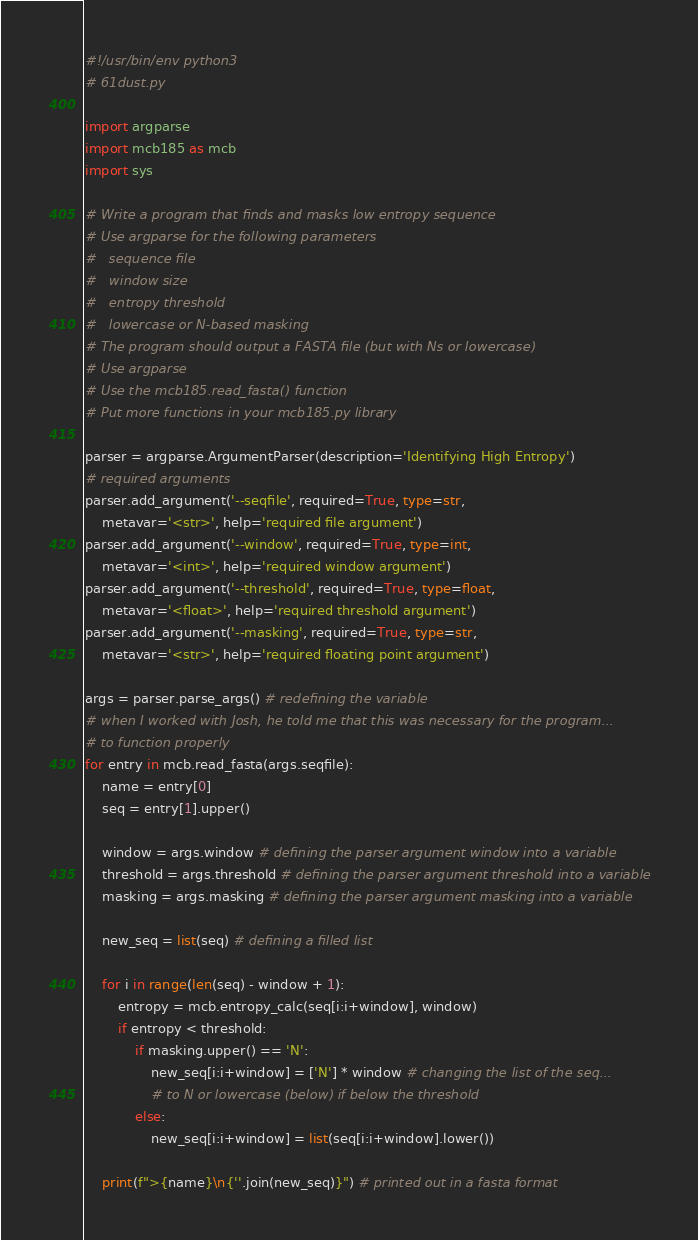<code> <loc_0><loc_0><loc_500><loc_500><_Python_>#!/usr/bin/env python3
# 61dust.py

import argparse
import mcb185 as mcb
import sys

# Write a program that finds and masks low entropy sequence
# Use argparse for the following parameters
#   sequence file
#   window size
#   entropy threshold
#   lowercase or N-based masking
# The program should output a FASTA file (but with Ns or lowercase)
# Use argparse
# Use the mcb185.read_fasta() function
# Put more functions in your mcb185.py library

parser = argparse.ArgumentParser(description='Identifying High Entropy')
# required arguments
parser.add_argument('--seqfile', required=True, type=str,
	metavar='<str>', help='required file argument')
parser.add_argument('--window', required=True, type=int,
	metavar='<int>', help='required window argument')
parser.add_argument('--threshold', required=True, type=float,
	metavar='<float>', help='required threshold argument')
parser.add_argument('--masking', required=True, type=str,
	metavar='<str>', help='required floating point argument')
	
args = parser.parse_args() # redefining the variable
# when I worked with Josh, he told me that this was necessary for the program...
# to function properly
for entry in mcb.read_fasta(args.seqfile):
	name = entry[0]
	seq = entry[1].upper()
	
	window = args.window # defining the parser argument window into a variable
	threshold = args.threshold # defining the parser argument threshold into a variable
	masking = args.masking # defining the parser argument masking into a variable

	new_seq = list(seq) # defining a filled list 

	for i in range(len(seq) - window + 1):
		entropy = mcb.entropy_calc(seq[i:i+window], window)
		if entropy < threshold:
			if masking.upper() == 'N':
				new_seq[i:i+window] = ['N'] * window # changing the list of the seq...
				# to N or lowercase (below) if below the threshold
			else:
				new_seq[i:i+window] = list(seq[i:i+window].lower())

	print(f">{name}\n{''.join(new_seq)}") # printed out in a fasta format






</code> 